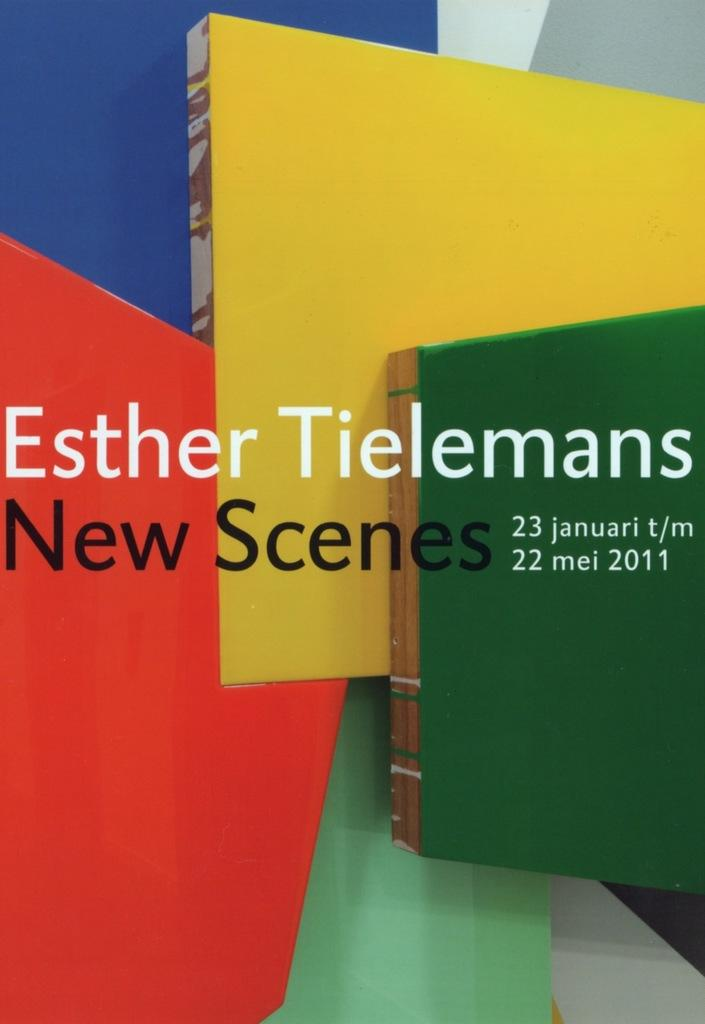<image>
Write a terse but informative summary of the picture. a paper that says 'esther tielemans new scenes' on it 